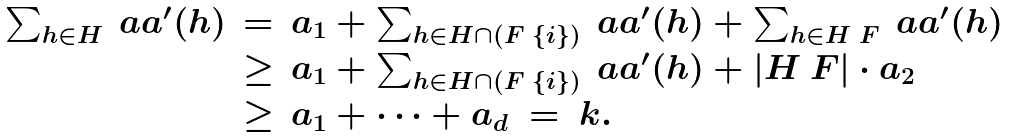<formula> <loc_0><loc_0><loc_500><loc_500>\begin{array} { c c l } \sum _ { h \in H } \ a a ^ { \prime } ( h ) & = & a _ { 1 } + \sum _ { h \in H \cap ( F \ \{ i \} ) } \ a a ^ { \prime } ( h ) + \sum _ { h \in H \ F } \ a a ^ { \prime } ( h ) \\ & \geq & a _ { 1 } + \sum _ { h \in H \cap ( F \ \{ i \} ) } \ a a ^ { \prime } ( h ) + | H \ F | \cdot a _ { 2 } \\ & \geq & a _ { 1 } + \dots + a _ { d } \ = \ k . \end{array}</formula> 